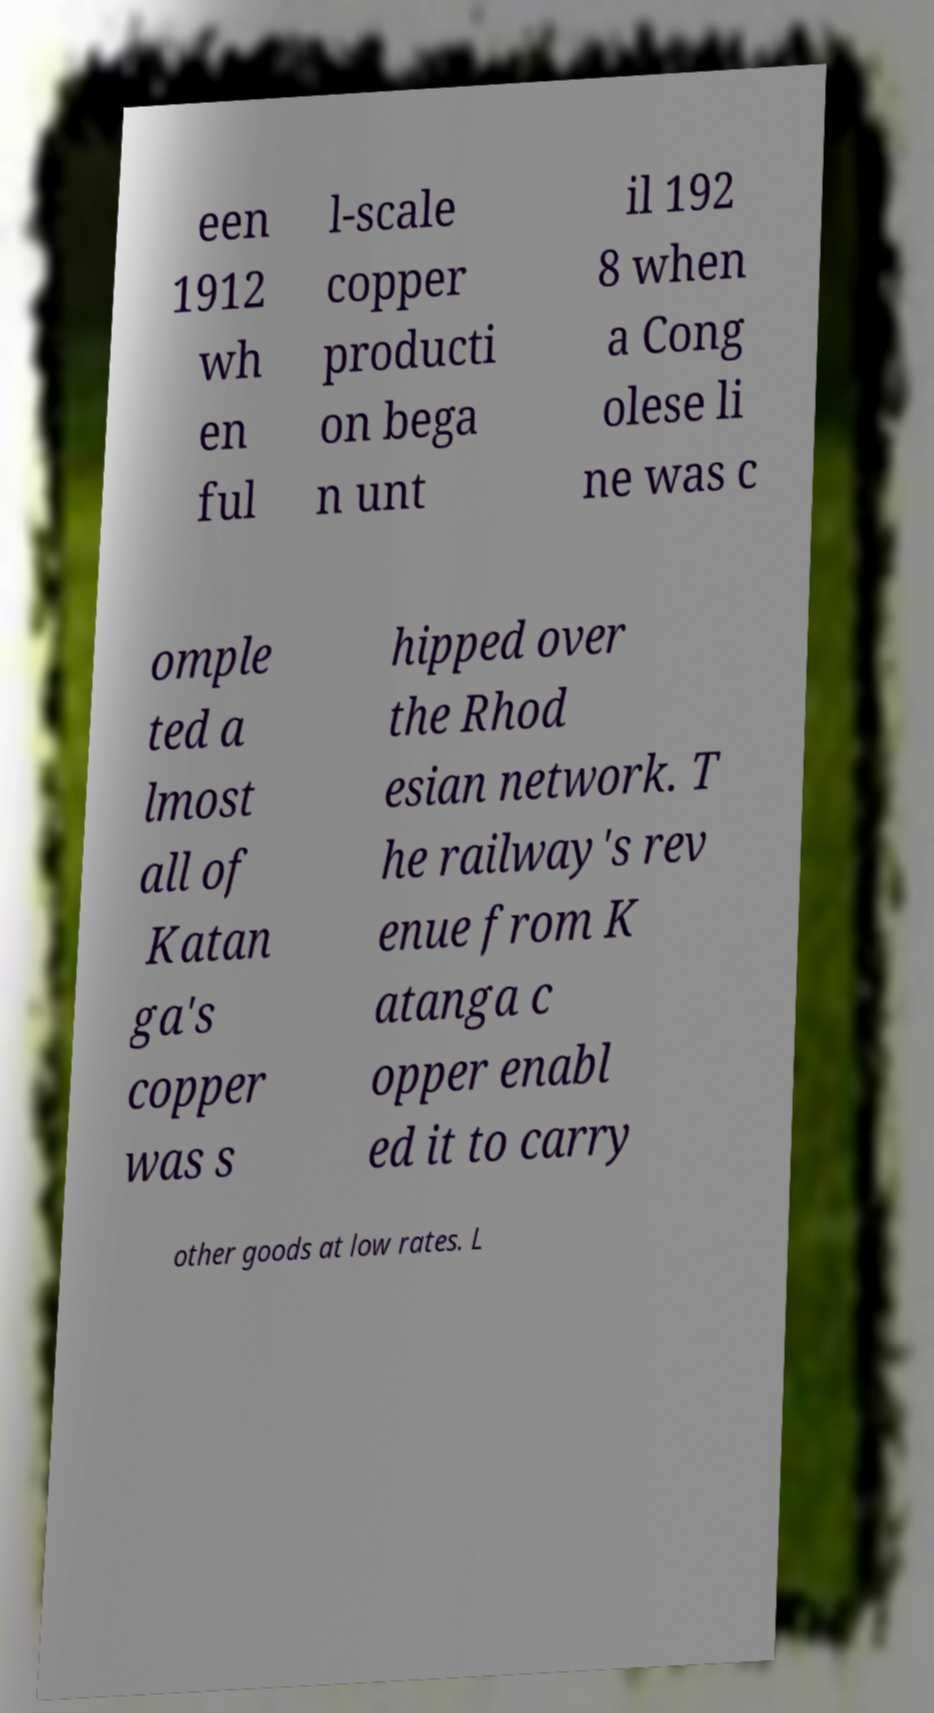For documentation purposes, I need the text within this image transcribed. Could you provide that? een 1912 wh en ful l-scale copper producti on bega n unt il 192 8 when a Cong olese li ne was c omple ted a lmost all of Katan ga's copper was s hipped over the Rhod esian network. T he railway's rev enue from K atanga c opper enabl ed it to carry other goods at low rates. L 